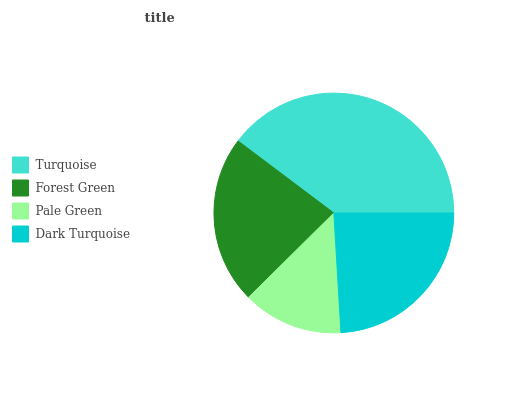Is Pale Green the minimum?
Answer yes or no. Yes. Is Turquoise the maximum?
Answer yes or no. Yes. Is Forest Green the minimum?
Answer yes or no. No. Is Forest Green the maximum?
Answer yes or no. No. Is Turquoise greater than Forest Green?
Answer yes or no. Yes. Is Forest Green less than Turquoise?
Answer yes or no. Yes. Is Forest Green greater than Turquoise?
Answer yes or no. No. Is Turquoise less than Forest Green?
Answer yes or no. No. Is Dark Turquoise the high median?
Answer yes or no. Yes. Is Forest Green the low median?
Answer yes or no. Yes. Is Turquoise the high median?
Answer yes or no. No. Is Dark Turquoise the low median?
Answer yes or no. No. 